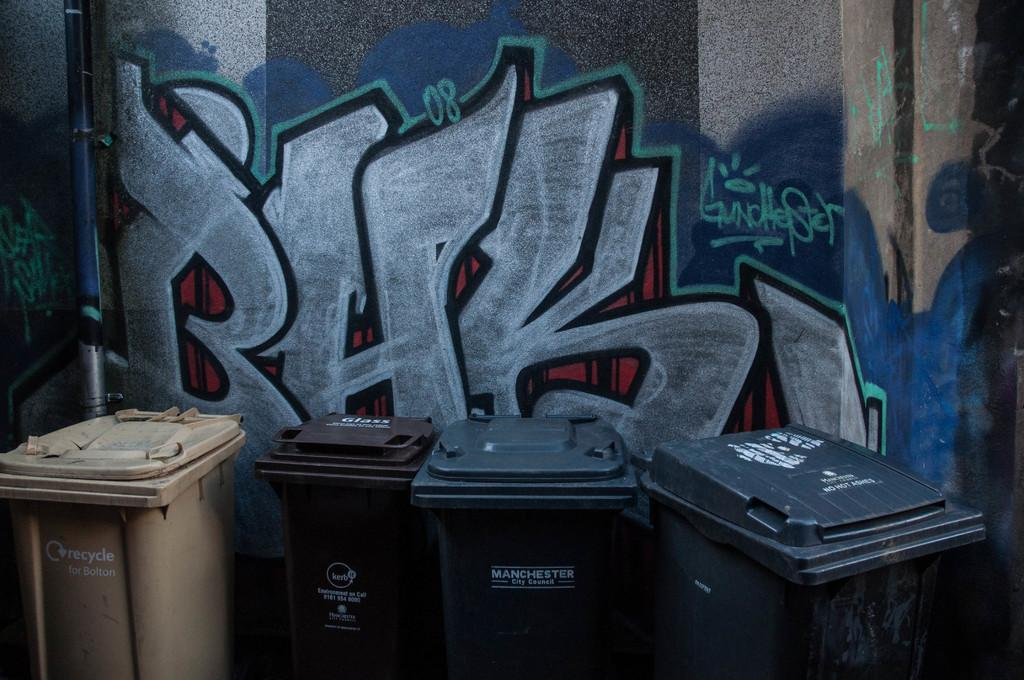<image>
Write a terse but informative summary of the picture. Garbage bins with Manchester city council written on the front of the bins. 